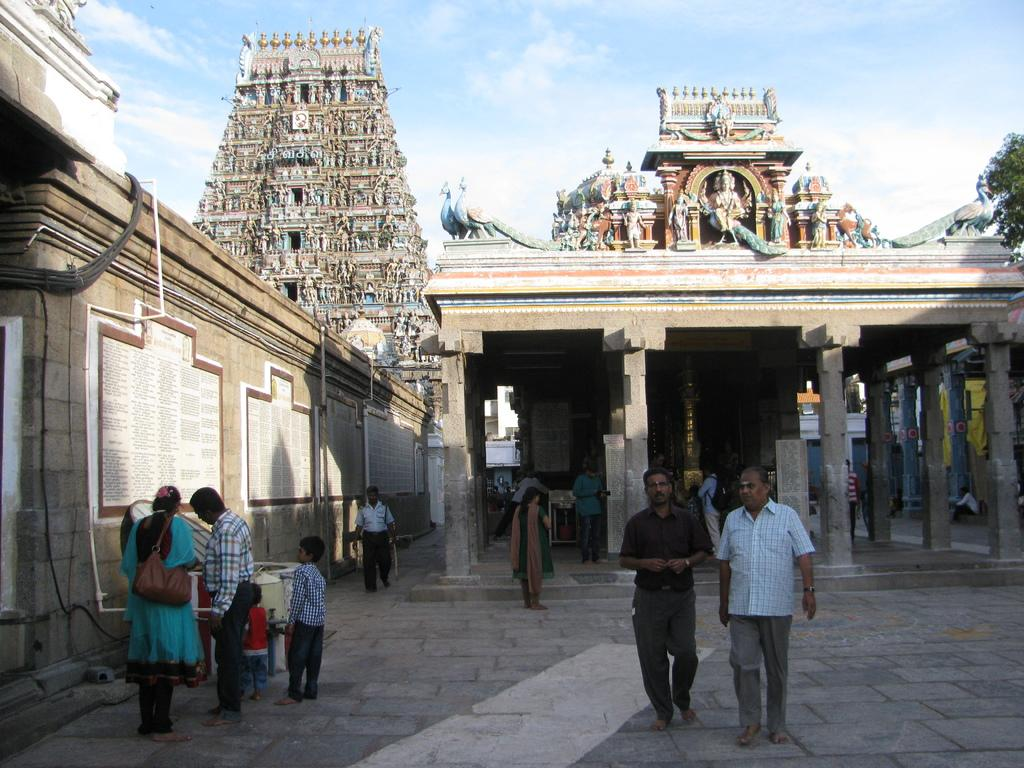What are the people in the image doing? The people in the image are standing and walking. What can be seen in the background of the image? There is a temple visible in the background. What type of vegetation is on the right side of the image? There is a tree on the right side of the image. What is visible at the top of the image? The sky is visible at the top of the image. What type of tooth is visible in the image? There is no tooth present in the image. What calculations can be seen being made on the calculator in the image? There is no calculator present in the image. 